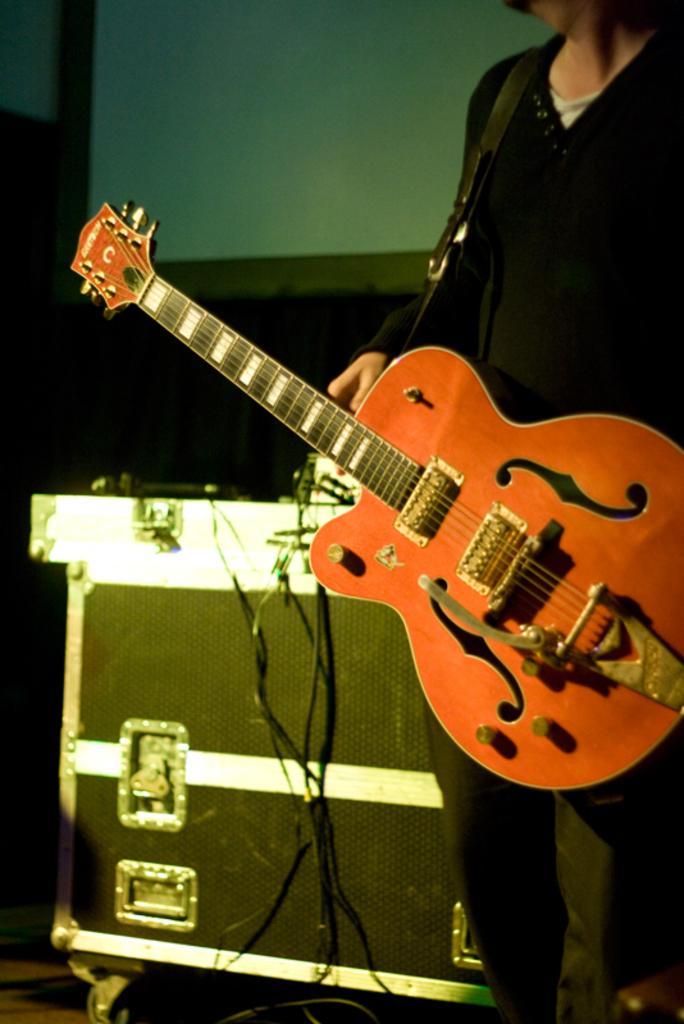Can you describe this image briefly? Person is wearing guitar,this is box. 